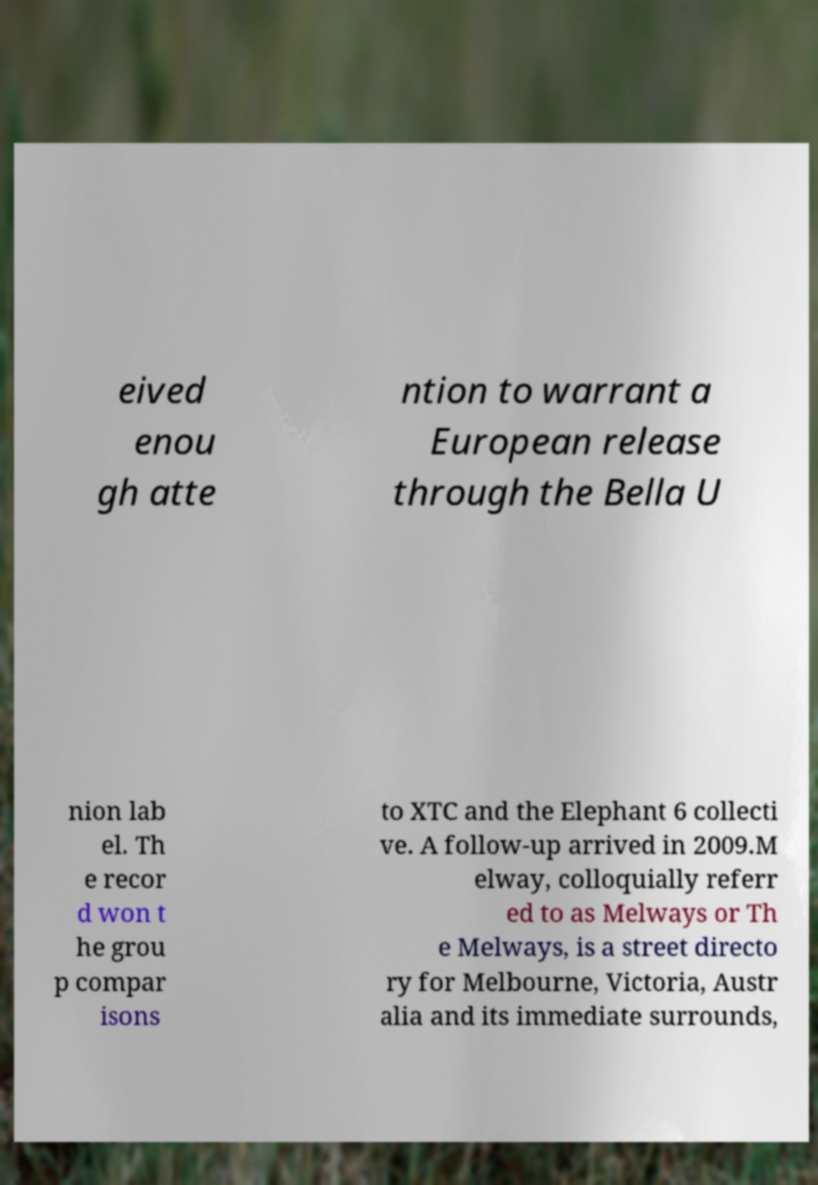Can you read and provide the text displayed in the image?This photo seems to have some interesting text. Can you extract and type it out for me? eived enou gh atte ntion to warrant a European release through the Bella U nion lab el. Th e recor d won t he grou p compar isons to XTC and the Elephant 6 collecti ve. A follow-up arrived in 2009.M elway, colloquially referr ed to as Melways or Th e Melways, is a street directo ry for Melbourne, Victoria, Austr alia and its immediate surrounds, 